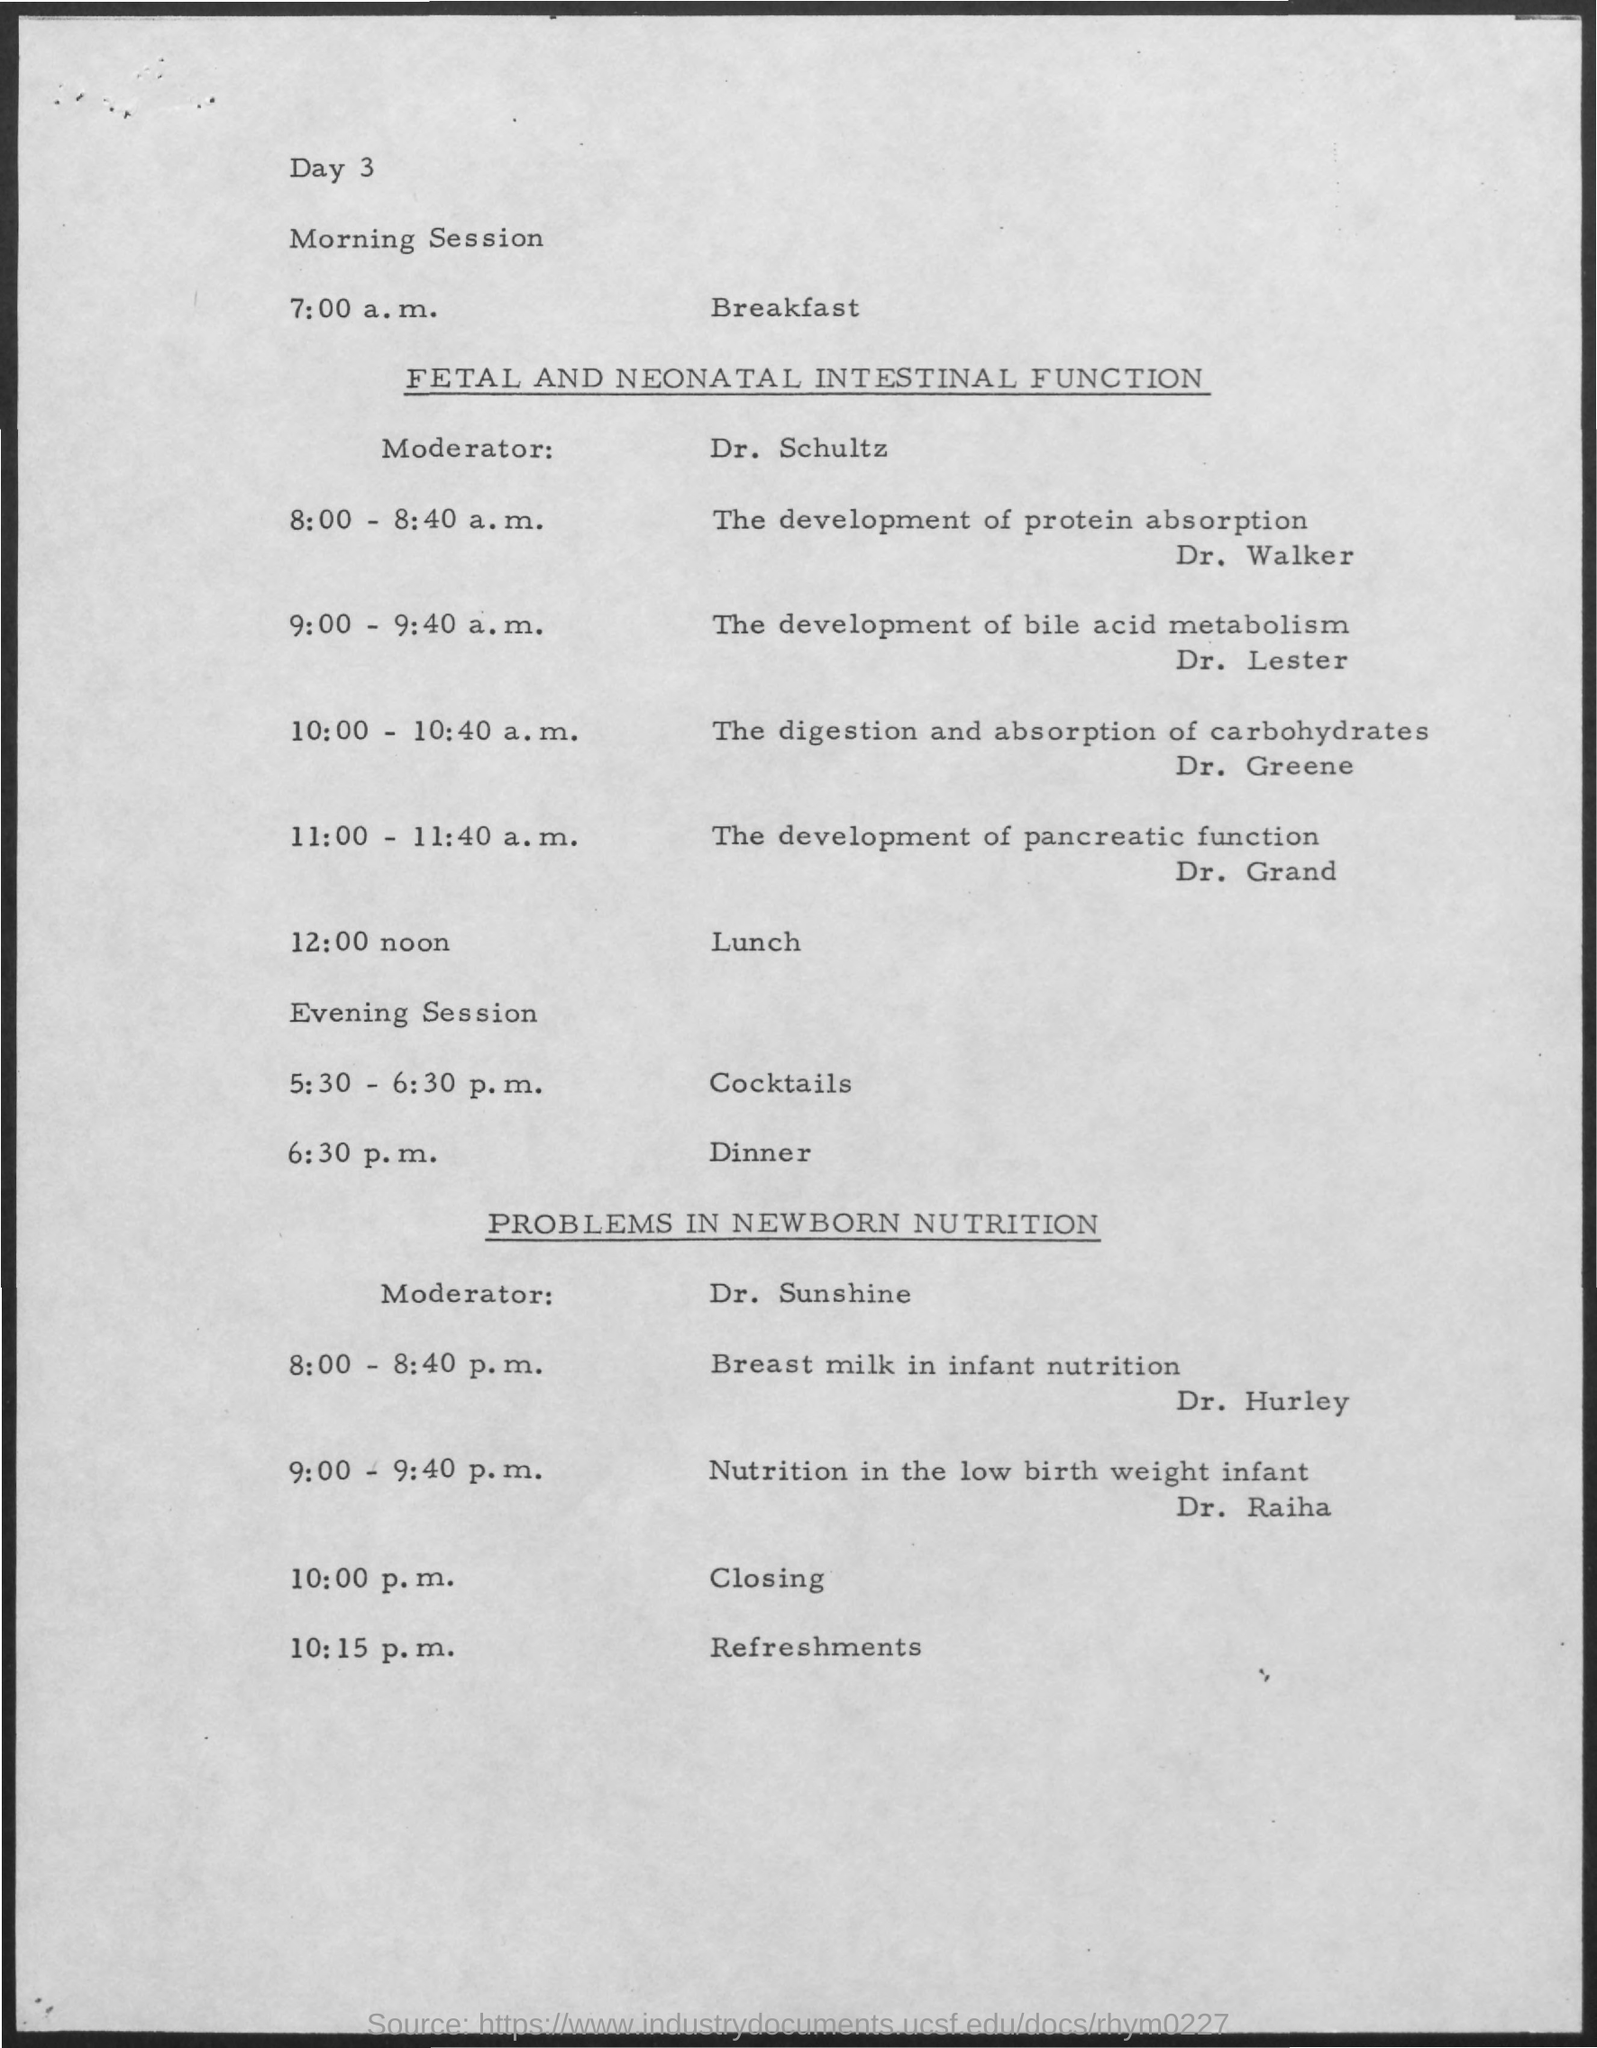Breakfast is scheduled at which time?
Provide a succinct answer. 7:00 a.m. 